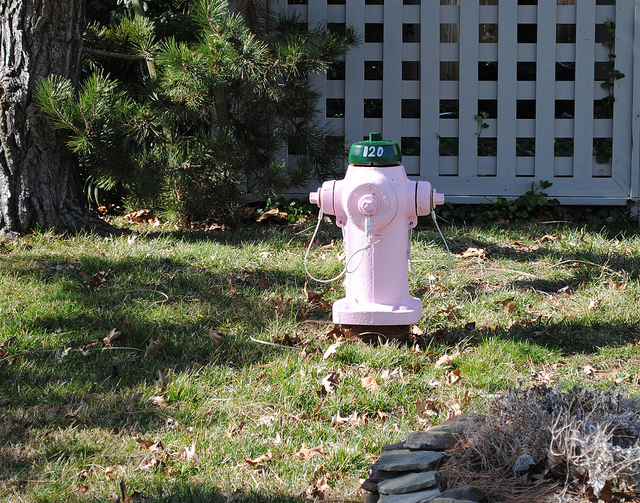Identify and read out the text in this image. 120 